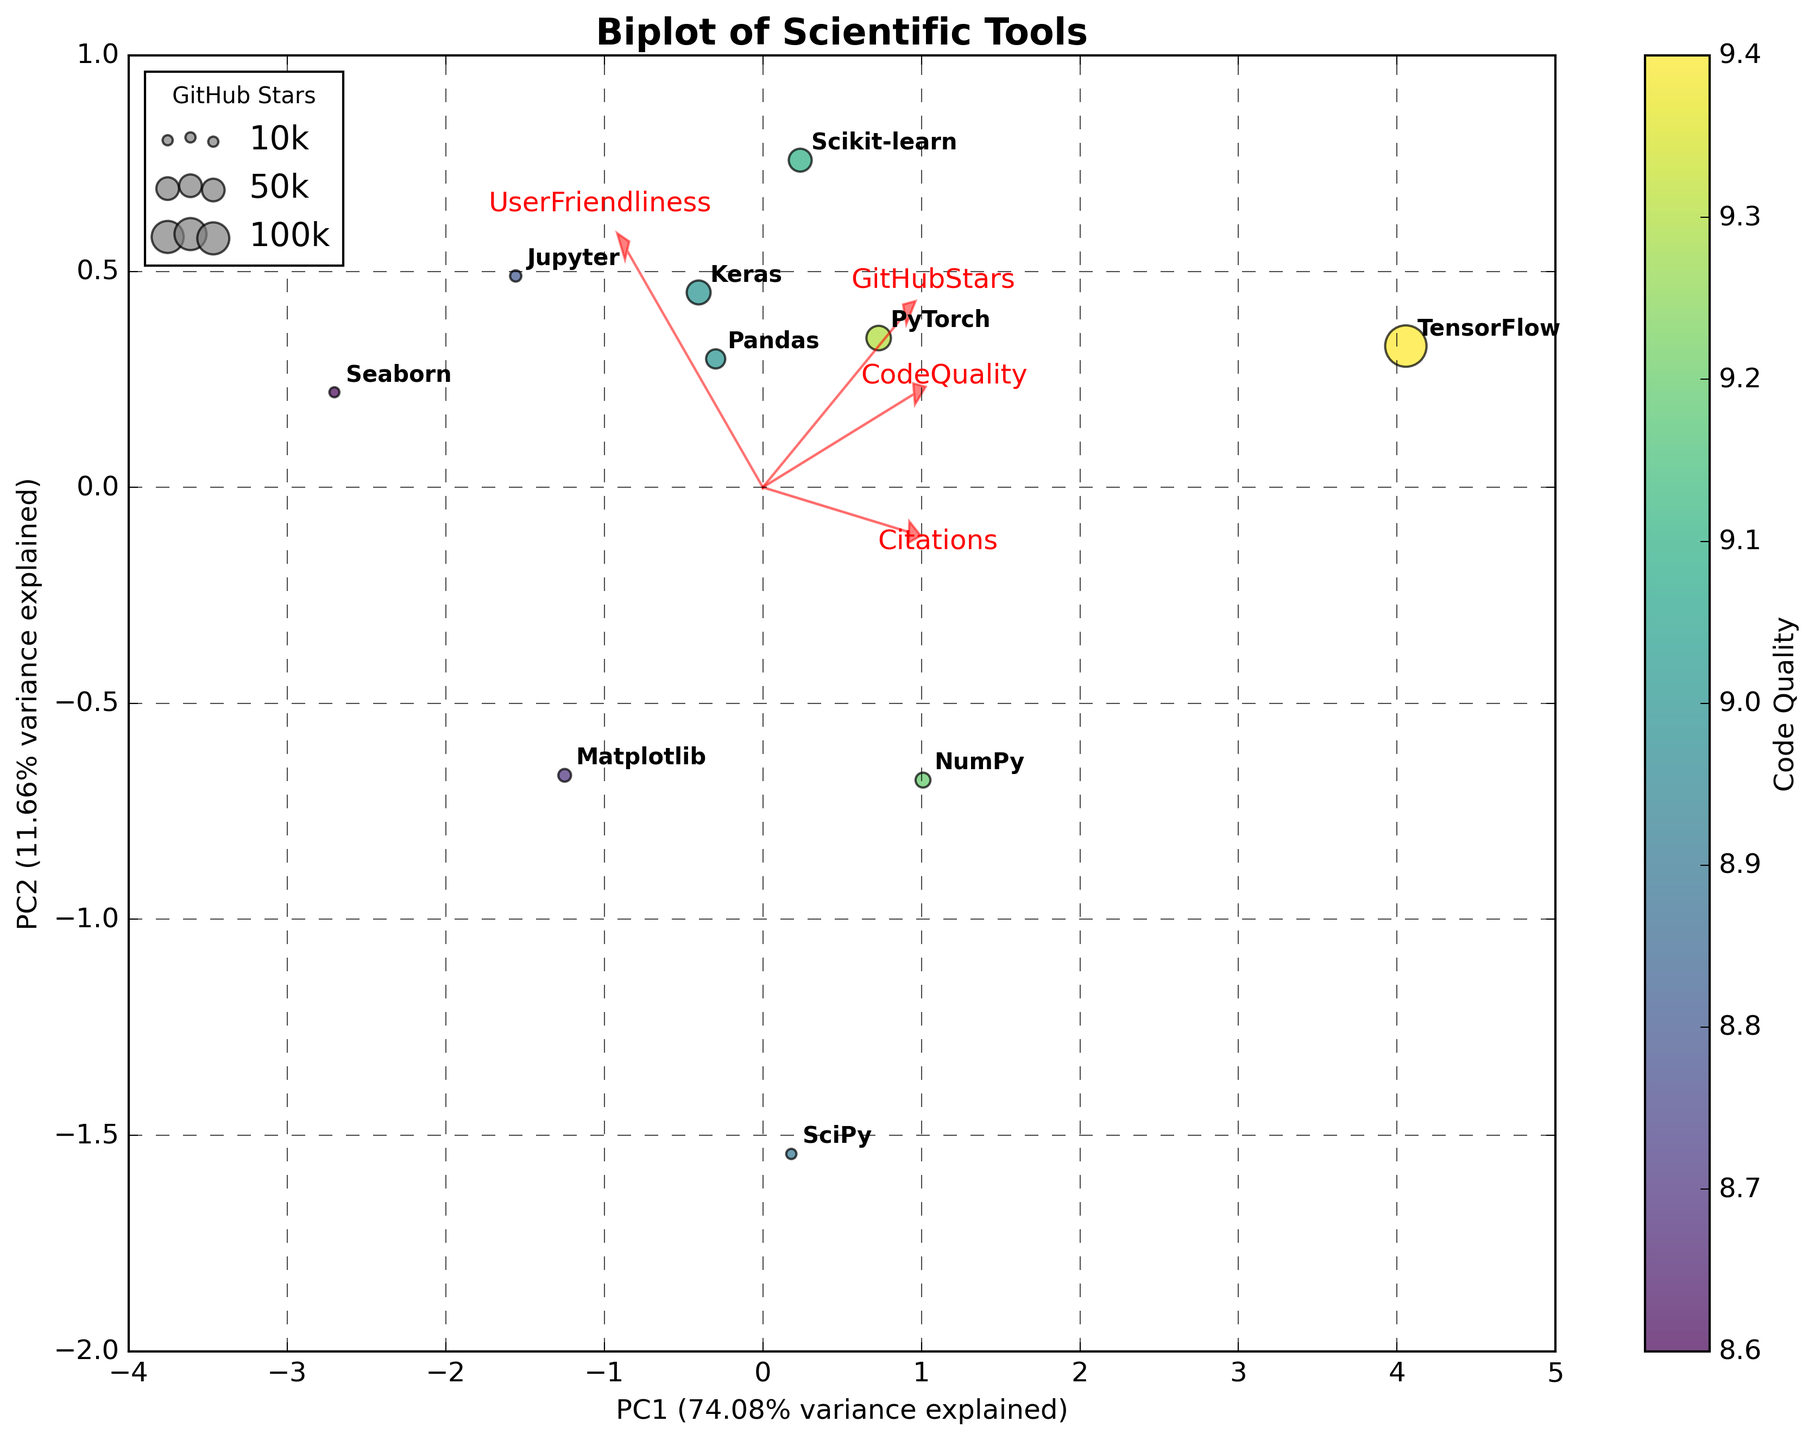Which tool has the highest number of citations? By looking at the scatter plot, we can identify the tool with the highest number of citations by finding the highest point along the PC1 axis that represents citations. TensorFlow is plotted at the highest position along this axis.
Answer: TensorFlow Which feature has the strongest loading on PC1? The loading vector’s length and direction indicate the contribution of each feature to PC1. The vector with the most extended projection on the PC1 axis represents the feature with the strongest loading. Citations have the most extended loading vector on PC1.
Answer: Citations How many tools have GitHub Stars greater than 50,000? We can estimate the size of the bubbles representing each tool by looking at their size in relation to the legend. TensorFlow and PyTorch are the only two tools with bubble sizes suggesting more than 50,000 GitHub Stars.
Answer: 2 Which tool has the highest code quality? The color intensity represents code quality; the deepest color from the colormap indicates the highest code quality. PyTorch has the deepest color, showing the highest code quality.
Answer: PyTorch Which feature is least correlated with PC2? The feature with the shortest loadings vector in the PC2 direction represents the least correlation with PC2. Citations have the shortest vector along the PC2 axis.
Answer: Citations What is the relationship between User Friendliness and PC2? We determine this relationship by examining the direction and length of the User Friendliness loading vector. The vector shows a substantial positive loading on PC2, suggesting a high correlation.
Answer: Positive correlation Which tool has the smallest bubble size on the plot? Bubbles represent GitHub Stars. The smallest size would be visually identifiable as the smallest bubble on the plot, which corresponds to Seaborn.
Answer: Seaborn How does Code Quality influence the data point colors in the plot? The colormap (viridis) used determines the bubble color based on the value of Code Quality. Higher code quality values are represented by deeper colors.
Answer: Higher code quality results in darker colors 